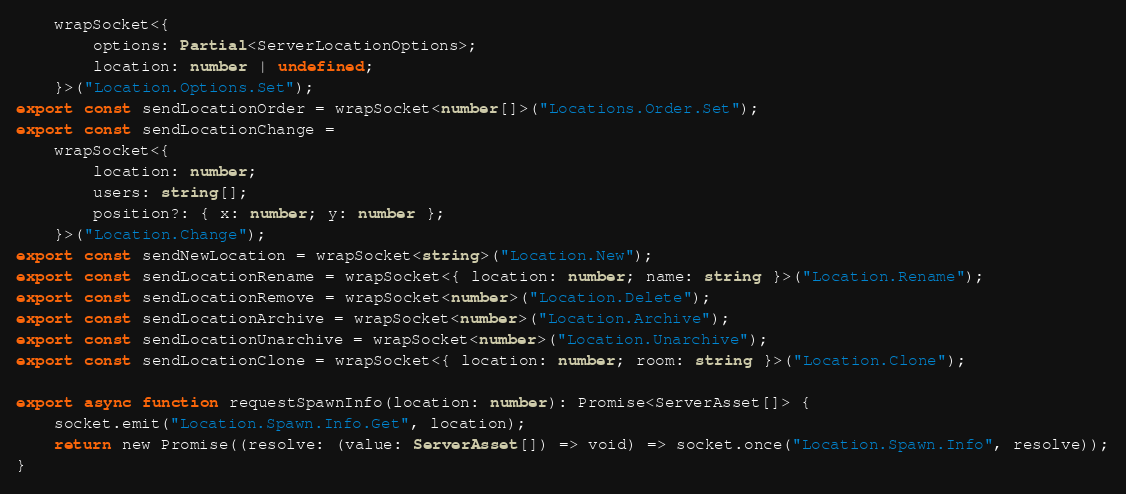<code> <loc_0><loc_0><loc_500><loc_500><_TypeScript_>    wrapSocket<{
        options: Partial<ServerLocationOptions>;
        location: number | undefined;
    }>("Location.Options.Set");
export const sendLocationOrder = wrapSocket<number[]>("Locations.Order.Set");
export const sendLocationChange =
    wrapSocket<{
        location: number;
        users: string[];
        position?: { x: number; y: number };
    }>("Location.Change");
export const sendNewLocation = wrapSocket<string>("Location.New");
export const sendLocationRename = wrapSocket<{ location: number; name: string }>("Location.Rename");
export const sendLocationRemove = wrapSocket<number>("Location.Delete");
export const sendLocationArchive = wrapSocket<number>("Location.Archive");
export const sendLocationUnarchive = wrapSocket<number>("Location.Unarchive");
export const sendLocationClone = wrapSocket<{ location: number; room: string }>("Location.Clone");

export async function requestSpawnInfo(location: number): Promise<ServerAsset[]> {
    socket.emit("Location.Spawn.Info.Get", location);
    return new Promise((resolve: (value: ServerAsset[]) => void) => socket.once("Location.Spawn.Info", resolve));
}
</code> 